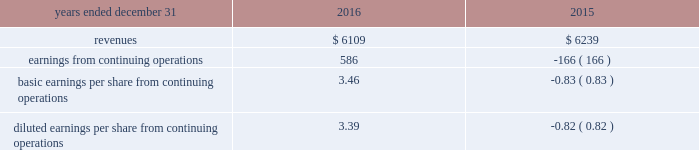The fair value of acquired property , plant and equipment , primarily network-related assets , was valued under the replacement cost method , which determines fair value based on the replacement cost of new property with similar capacity , adjusted for physical deterioration over the remaining useful life .
Goodwill is calculated as the excess of the consideration transferred over the net assets recognized and represents the future economic benefits arising from the other assets acquired that could not be individually identified and separately recognized .
Goodwill is not deductible for tax purposes .
Pro forma financial information the table presents the unaudited pro forma combined results of operations of the company and gdcl for the years ended december 31 , 2016 and december 31 , 2015 as if the acquisition of gdcl had occurred on january 1 , 2016 and january 1 , 2015 , respectively , ( in millions , except per share amounts ) : .
The company did not adjust the effects of an $ 884 million goodwill impairment charge reported in the historic results of gdcl for the year ended december 31 , 2015 on the basis that the goodwill impairment charge was not directly attributable to the acquisition of gdcl by the company .
However , this goodwill impairment charge should be highlighted as unusual and non- recurring .
The pro forma results are based on estimates and assumptions , which the company believes are reasonable .
They are not necessarily indicative of its consolidated results of operations in future periods or the results that actually would have been realized had we been a combined company during the periods presented .
The pro forma results include adjustments primarily related to amortization of acquired intangible assets , depreciation , interest expense , and transaction costs expensed during the period .
Other acquisitions on november 18 , 2014 , the company completed the acquisition of an equipment provider for a purchase price of $ 22 million .
During the year ended december 31 , 2015 , the company completed the purchase accounting for this acquisition , recognizing $ 6 million of goodwill and $ 12 million of identifiable intangible assets .
These identifiable intangible assets were classified as completed technology to be amortized over five years .
During the year ended december 31 , 2015 , the company completed the acquisitions of two providers of public safety software-based solutions for an aggregate purchase price of $ 50 million , recognizing an additional $ 31 million of goodwill , $ 22 million of identifiable intangible assets , and $ 3 million of acquired liabilities related to these acquisitions .
The $ 22 million of identifiable intangible assets were classified as : ( i ) $ 11 million completed technology , ( ii ) $ 8 million customer-related intangibles , and ( iii ) $ 3 million of other intangibles .
These intangible assets will be amortized over periods ranging from five to ten years .
On november 10 , 2016 , the company completed the acquisition of spillman technologies , a provider of comprehensive law enforcement and public safety software solutions , for a gross purchase price of $ 217 million .
As a result of the acquisition , the company recognized $ 140 million of goodwill , $ 115 million of identifiable intangible assets , and $ 38 million of acquired liabilities .
The identifiable intangible assets were classified as $ 49 million of completed technology , $ 59 million of customer- related intangibles , and $ 7 million of other intangibles and will be amortized over a period of seven to ten years .
As of december 31 , 2016 , the purchase accounting is not yet complete .
The final allocation may include : ( i ) changes in fair values of acquired goodwill and ( ii ) changes to assets and liabilities .
During the year ended december 31 , 2016 , the company completed the acquisition of several software and service-based providers for a total of $ 30 million , recognizing $ 6 million of goodwill , $ 15 million of intangible assets , and $ 9 million of tangible net assets related to the these acquisitions .
The $ 15 million of identifiable intangible assets were classified as : ( i ) $ 7 million of completed technology and ( ii ) $ 8 million of customer-related intangibles and will be amortized over a period of five years .
As of december 31 , 2016 , the purchase accounting has not been completed for one acquisition which was purchased in late 2016 .
As such , an amount of $ 11 million has been recorded within other assets as of december 31 , 2016 .
The purchase accounting is expected to be completed in the first quarter of 2017 .
The results of operations for these acquisitions have been included in the company 2019s condensed consolidated statements of operations subsequent to the acquisition date .
The pro forma effects of these acquisitions are not significant individually or in the aggregate. .
As part of the company completed the acquisition of several software and service-based providers in december 31 , 2016 what was the percent of the goodwill recognized to the purchase price? 
Computations: (6 / 30)
Answer: 0.2. 